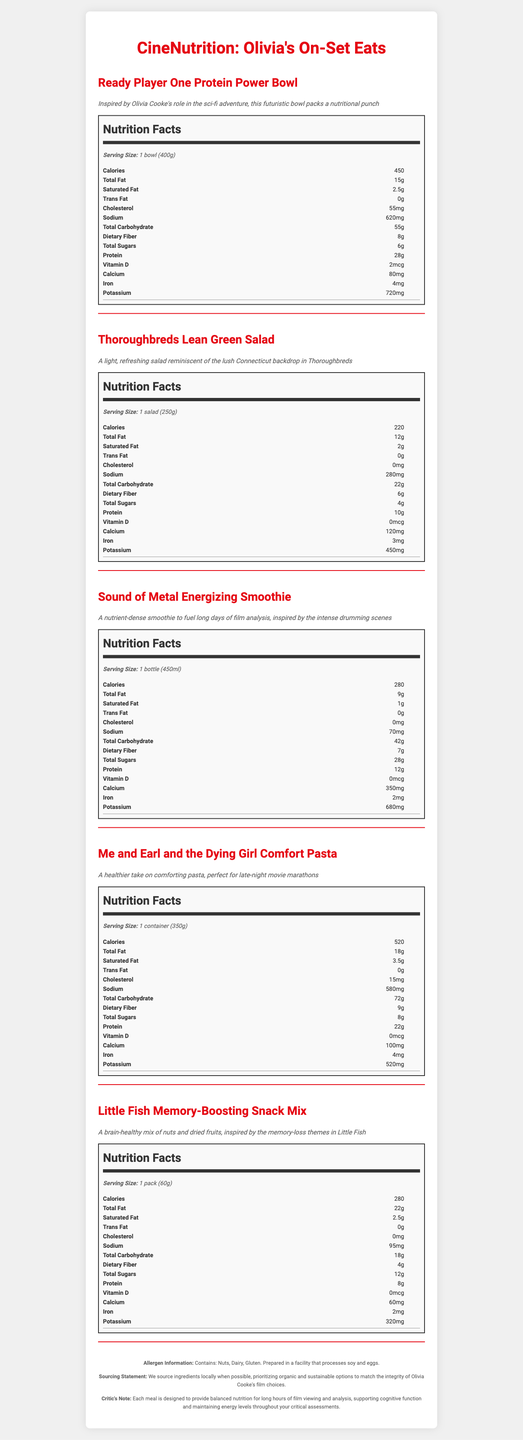what is the serving size for the Ready Player One Protein Power Bowl? The document specifies that the serving size for the Ready Player One Protein Power Bowl is one bowl, weighing 400 grams.
Answer: 1 bowl (400g) what is the total carbohydrate content in the Thoroughbreds Lean Green Salad? The nutrition label for the Thoroughbreds Lean Green Salad lists total carbohydrates as 22 grams.
Answer: 22 grams how many calories are in the Sound of Metal Energizing Smoothie? The Sound of Metal Energizing Smoothie contains 280 calories, as indicated in the nutrition label.
Answer: 280 calories which dish has the highest protein content? The Ready Player One Protein Power Bowl has 28 grams of protein, which is the highest among the listed dishes.
Answer: Ready Player One Protein Power Bowl how much dietary fiber is in the Me and Earl and the Dying Girl Comfort Pasta? The nutrition facts for the Me and Earl and the Dying Girl Comfort Pasta show a dietary fiber content of 9 grams.
Answer: 9 grams which dish contains the least amount of sodium? A. Ready Player One Protein Power Bowl B. Thoroughbreds Lean Green Salad C. Sound of Metal Energizing Smoothie D. Little Fish Memory-Boosting Snack Mix The Sound of Metal Energizing Smoothie contains 70 mg of sodium, which is the least compared to the other options: 620 mg in Ready Player One Protein Power Bowl, 280 mg in Thoroughbreds Lean Green Salad, and 95 mg in Little Fish Memory-Boosting Snack Mix.
Answer: C. Sound of Metal Energizing Smoothie which of the following contains the most calcium? I. Ready Player One Protein Power Bowl II. Thoroughbreds Lean Green Salad III. Sound of Metal Energizing Smoothie The Sound of Metal Energizing Smoothie contains 350 mg of calcium, which is more than the Ready Player One Protein Power Bowl's 80 mg and Thoroughbreds Lean Green Salad's 120 mg.
Answer: III. Sound of Metal Energizing Smoothie is there any trans fat in the Little Fish Memory-Boosting Snack Mix? The nutrition label states that the Little Fish Memory-Boosting Snack Mix contains 0 grams of trans fat.
Answer: No summarize the main purpose of this document. This document serves to present a detailed overview of the nutrition and inspiration behind each menu item in the CineNutrition meal prep service, emphasizing both health benefits and cinematic themes related to Olivia Cooke's films.
Answer: The document provides detailed nutritional information for a film critic's meal prep service called "CineNutrition: Olivia's On-Set Eats," featuring dishes inspired by Olivia Cooke's movie roles. Each menu item includes a description, serving size, and a full nutrition label. The document also includes allergen information, a sourcing statement, and a note emphasising the meals' design to support long hours of film viewing and analysis. what are the main allergens present in these dishes? The allergen information section indicates that the dishes contain nuts, dairy, and gluten.
Answer: Nuts, Dairy, Gluten what meal is perfect for a late-night movie marathon? The description for the Me and Earl and the Dying Girl Comfort Pasta states that it is perfect for a late-night movie marathon.
Answer: Me and Earl and the Dying Girl Comfort Pasta how much potassium is in the Ready Player One Protein Power Bowl? The nutrition label for the Ready Player One Protein Power Bowl shows 720 mg of potassium.
Answer: 720 mg is Olivia Cooke the chef behind these recipes? The document does not provide any information suggesting that Olivia Cooke is directly involved in preparing or creating the recipes.
Answer: Not enough information how much cholesterol is in the Sound of Metal Energizing Smoothie? The nutrition facts for the Sound of Metal Energizing Smoothie indicate that it contains 0 mg of cholesterol.
Answer: 0 mg 